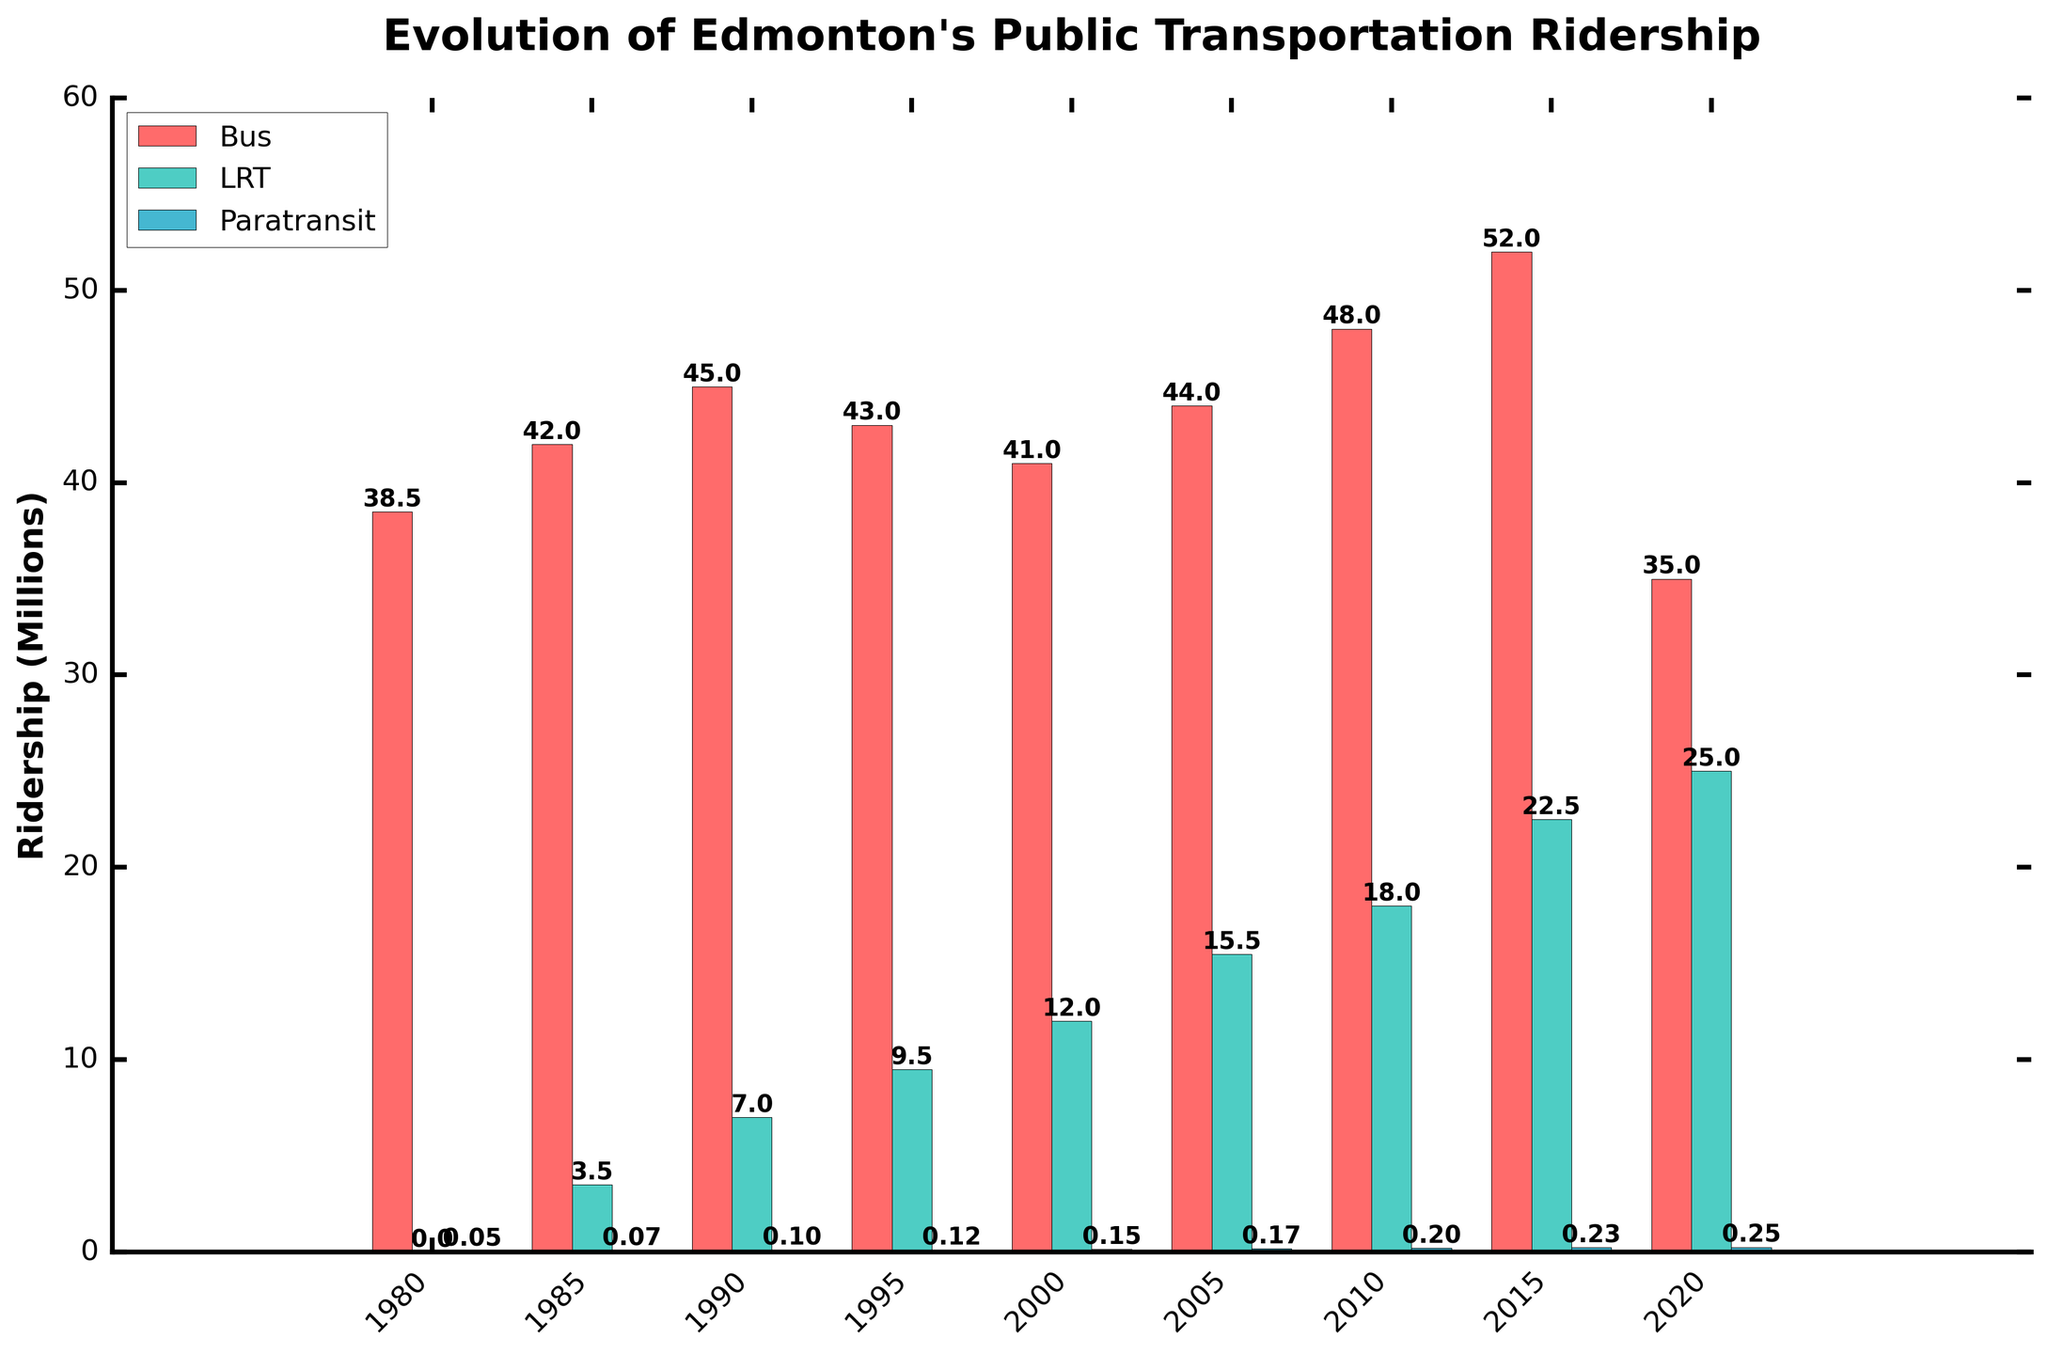What year had the highest total ridership across all modes? To find the year with the highest total ridership, sum the ridership of all modes for each year and compare the totals. The highest total is in 2015, which is 52 + 22.5 + 0.225 = 74.725 million.
Answer: 2015 Which mode of transportation saw the most consistent growth from 1980 to 2015? By examining the trends of each mode, the Light Rail Transit (LRT) displays consistent growth from 1980 to 2015, increasing from 0 to 22.5 million riders.
Answer: LRT How did bus ridership in 2020 compare to bus ridership in 2015? In 2015, bus ridership was 52 million, and in 2020 it dropped to 35 million. So bus ridership in 2020 was 17 million less than in 2015.
Answer: 17 million less Which year had the lowest paratransit ridership? The lowest paratransit ridership occurred in 1980 with only 0.05 million riders.
Answer: 1980 If we average the bus ridership over the 40-year period, what is the result? To find the average bus ridership, sum the bus ridership from all years and divide by the number of years. (38.5 + 42 + 45 + 43 + 41 + 44 + 48 + 52 + 35) / 9 = 42.1 million.
Answer: 42.1 million What is the difference between the LRT ridership in 2020 and 1985? The LRT ridership in 1985 was 3.5 million and in 2020 it was 25 million. The difference is 25 - 3.5 = 21.5 million.
Answer: 21.5 million Which mode had the smallest overall increase from 1980 to 2020? By comparing the increase for all modes, the smallest increase is in paratransit ridership, which increased by 0.25 - 0.05 = 0.2 million riders.
Answer: Paratransit What was Edmonton's total public transportation ridership in 2000? To find the total in 2000, sum the ridership for all modes: 41 + 12 + 0.15 = 53.15 million.
Answer: 53.15 million How many years saw an increase in LRT ridership compared to the previous recorded year? By examining the LRT ridership values, increases occurred from 1985 to 2020 with every recorded year seeing an increase. The count of such years is 8.
Answer: 8 